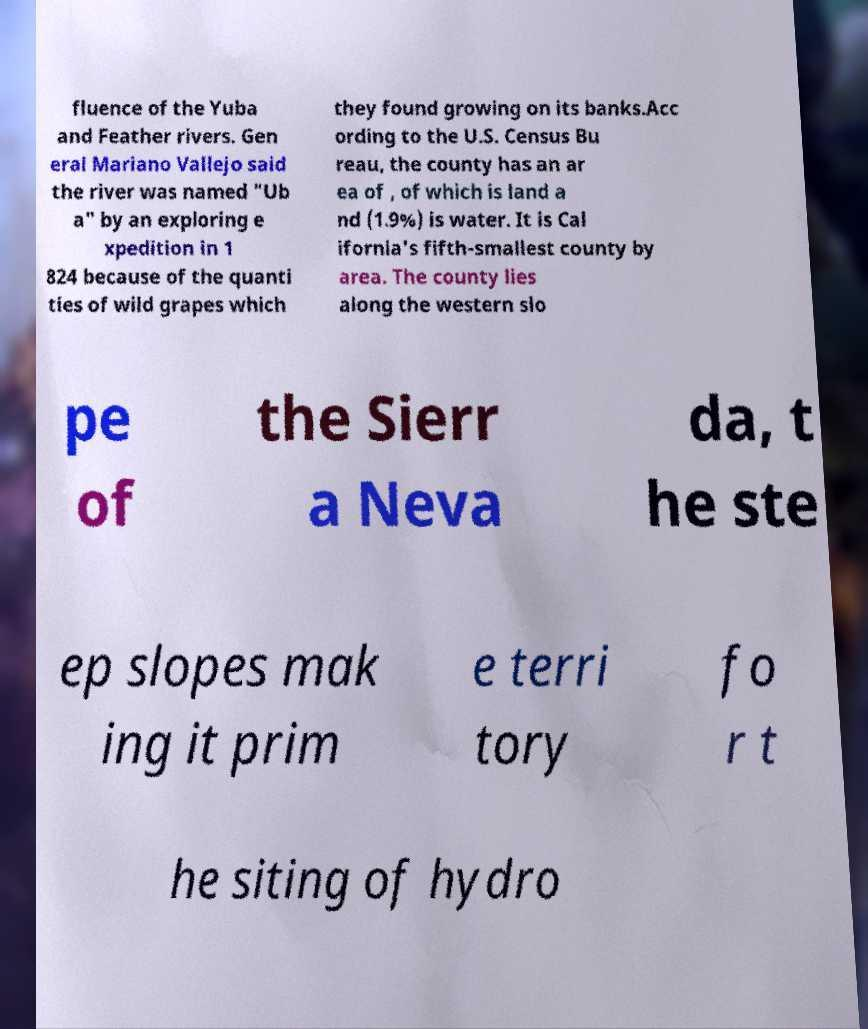Could you extract and type out the text from this image? fluence of the Yuba and Feather rivers. Gen eral Mariano Vallejo said the river was named "Ub a" by an exploring e xpedition in 1 824 because of the quanti ties of wild grapes which they found growing on its banks.Acc ording to the U.S. Census Bu reau, the county has an ar ea of , of which is land a nd (1.9%) is water. It is Cal ifornia's fifth-smallest county by area. The county lies along the western slo pe of the Sierr a Neva da, t he ste ep slopes mak ing it prim e terri tory fo r t he siting of hydro 